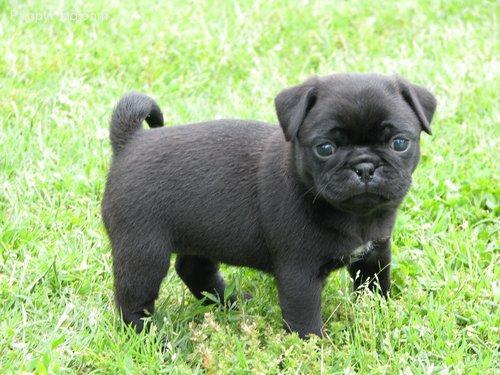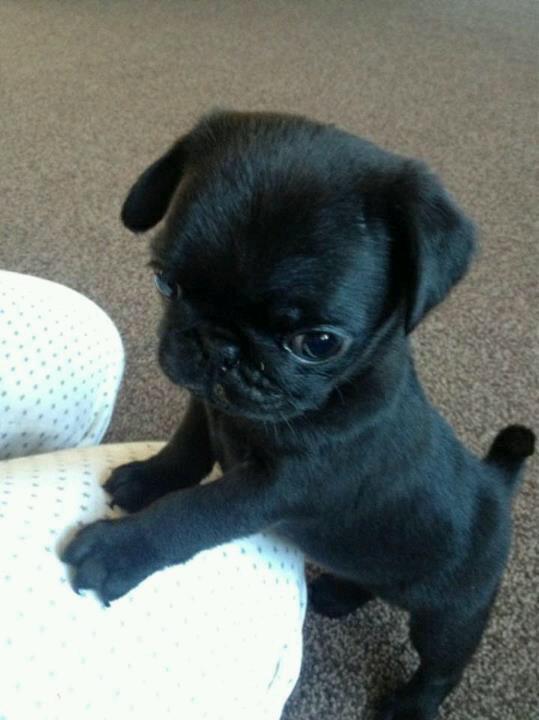The first image is the image on the left, the second image is the image on the right. Given the left and right images, does the statement "An image shows one black pug, with its tongue out." hold true? Answer yes or no. No. The first image is the image on the left, the second image is the image on the right. Examine the images to the left and right. Is the description "One of the dogs is standing in the grass." accurate? Answer yes or no. Yes. 